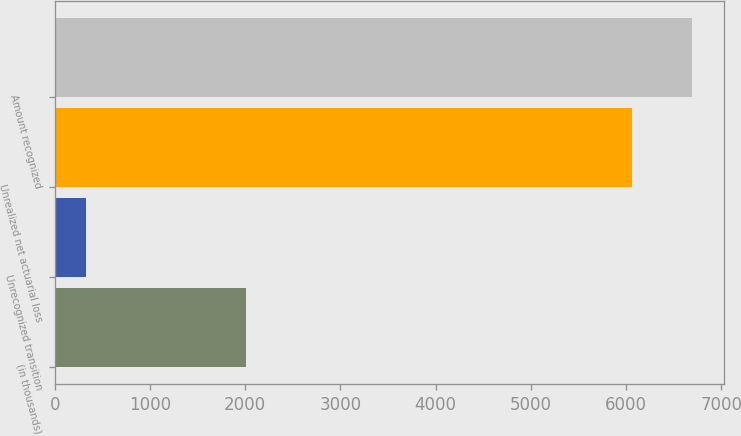Convert chart. <chart><loc_0><loc_0><loc_500><loc_500><bar_chart><fcel>(in thousands)<fcel>Unrecognized transition<fcel>Unrealized net actuarial loss<fcel>Amount recognized<nl><fcel>2008<fcel>324<fcel>6068<fcel>6697.1<nl></chart> 